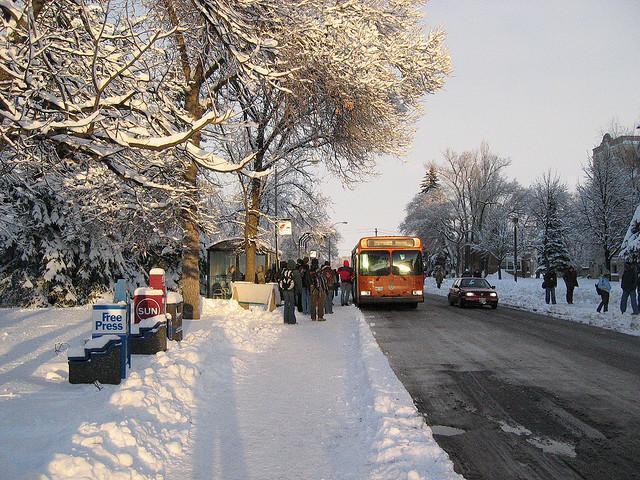How many care do you see?
Give a very brief answer. 1. 